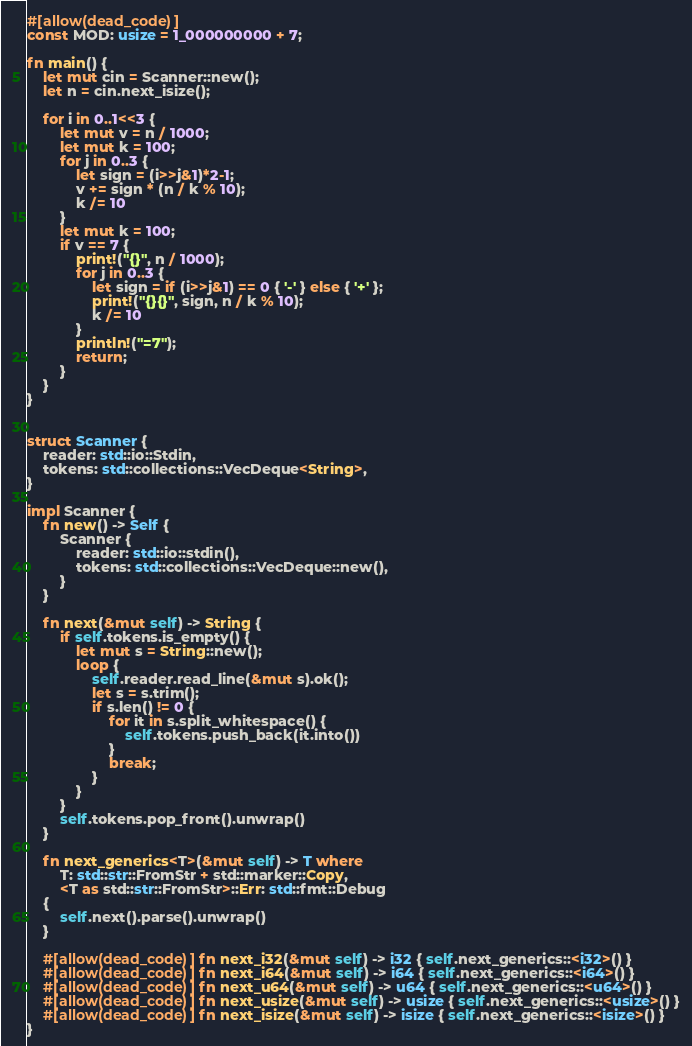Convert code to text. <code><loc_0><loc_0><loc_500><loc_500><_Rust_>
#[allow(dead_code)]
const MOD: usize = 1_000000000 + 7;

fn main() {
    let mut cin = Scanner::new();
    let n = cin.next_isize();

    for i in 0..1<<3 {
        let mut v = n / 1000;
        let mut k = 100;
        for j in 0..3 {
            let sign = (i>>j&1)*2-1;
            v += sign * (n / k % 10);
            k /= 10
        }
        let mut k = 100;
        if v == 7 {
            print!("{}", n / 1000);
            for j in 0..3 {
                let sign = if (i>>j&1) == 0 { '-' } else { '+' };
                print!("{}{}", sign, n / k % 10);
                k /= 10
            }
            println!("=7");
            return;
        }
    }
}


struct Scanner {
    reader: std::io::Stdin,
    tokens: std::collections::VecDeque<String>,
}

impl Scanner {
    fn new() -> Self {
        Scanner {
            reader: std::io::stdin(),
            tokens: std::collections::VecDeque::new(),
        }
    }

    fn next(&mut self) -> String {
        if self.tokens.is_empty() {
            let mut s = String::new();
            loop {
                self.reader.read_line(&mut s).ok();
                let s = s.trim();
                if s.len() != 0 {
                    for it in s.split_whitespace() {
                        self.tokens.push_back(it.into())
                    }
                    break;
                }
            }
        }
        self.tokens.pop_front().unwrap()
    }

    fn next_generics<T>(&mut self) -> T where
        T: std::str::FromStr + std::marker::Copy,
        <T as std::str::FromStr>::Err: std::fmt::Debug
    {
        self.next().parse().unwrap()
    }
    
    #[allow(dead_code)] fn next_i32(&mut self) -> i32 { self.next_generics::<i32>() }
    #[allow(dead_code)] fn next_i64(&mut self) -> i64 { self.next_generics::<i64>() }
    #[allow(dead_code)] fn next_u64(&mut self) -> u64 { self.next_generics::<u64>() }
    #[allow(dead_code)] fn next_usize(&mut self) -> usize { self.next_generics::<usize>() }
    #[allow(dead_code)] fn next_isize(&mut self) -> isize { self.next_generics::<isize>() }
}

</code> 